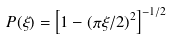<formula> <loc_0><loc_0><loc_500><loc_500>P ( \xi ) = { \left [ 1 - { ( \pi \xi / 2 ) } ^ { 2 } \right ] } ^ { - 1 / 2 }</formula> 